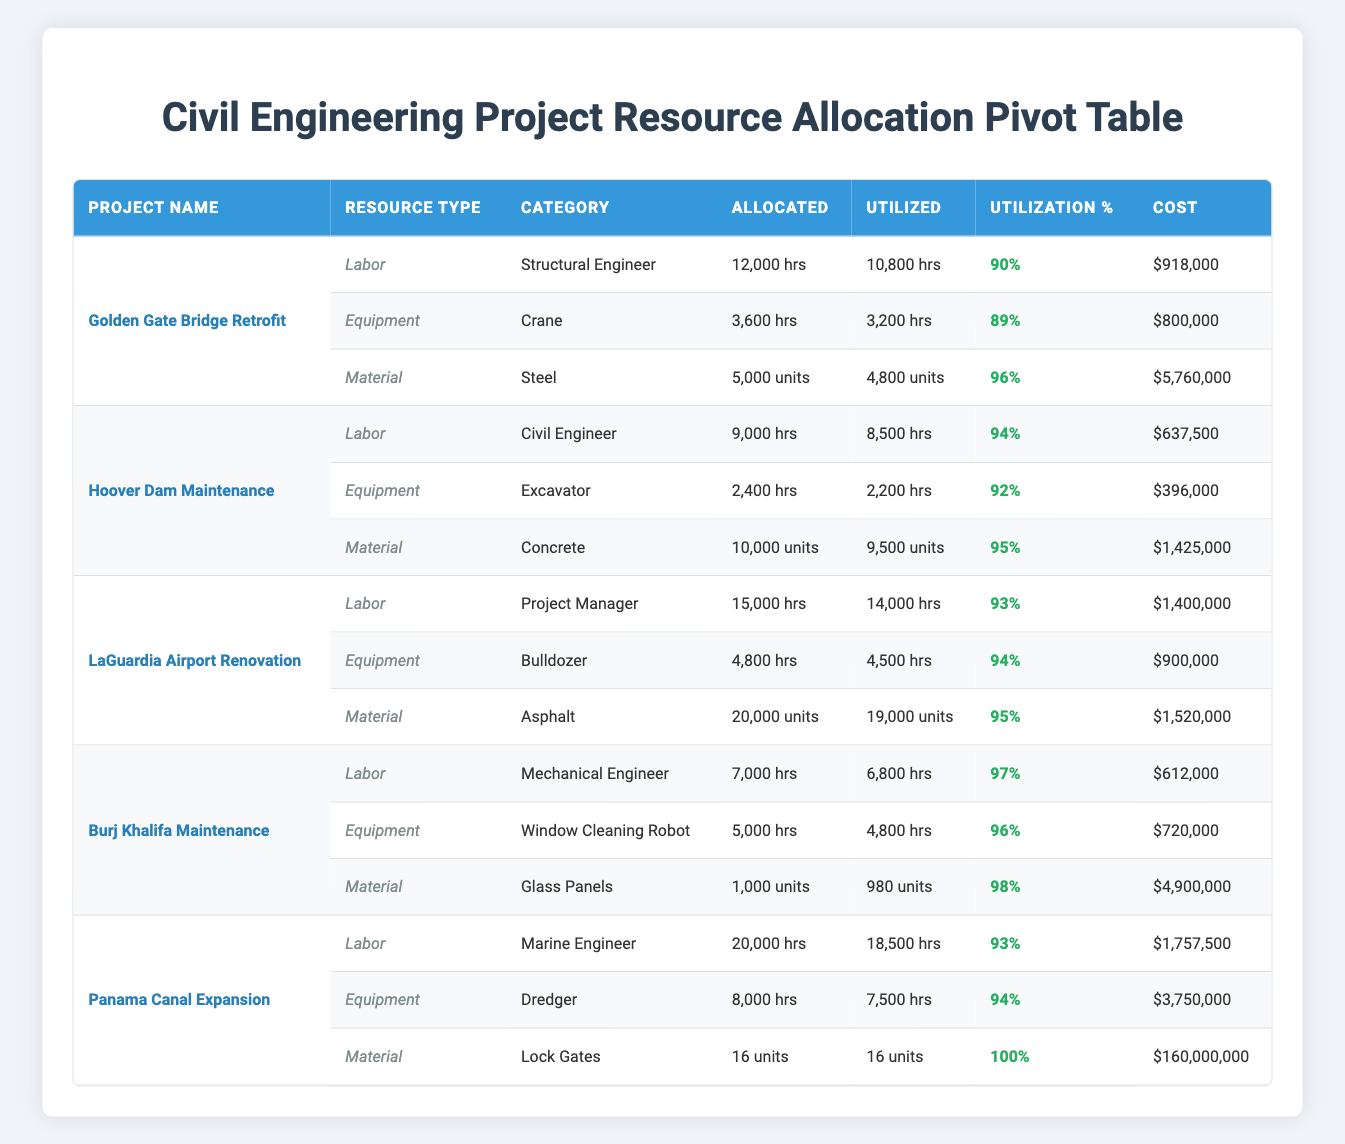What is the total budget for all projects? The total budget can be calculated by adding the budgets of all projects: 250,000,000 + 180,000,000 + 500,000,000 + 100,000,000 + 750,000,000 = 1,780,000,000.
Answer: 1,780,000,000 Which project has the highest resource utilization for Labor? By comparing the Labor utilization percentages for each project, we find the highest is from "Burj Khalifa Maintenance" at 97%.
Answer: Burj Khalifa Maintenance How many hours was Equipment utilized for the Panama Canal Expansion? The table states that Equipment for the Panama Canal Expansion had a utilization of 7,500 hours.
Answer: 7,500 hrs Is the utilization percentage for Steel higher than that for Concrete? The utilization for Steel is 96% and for Concrete is 95%. Since 96% is greater than 95%, the statement is true.
Answer: Yes What is the total cost incurred for Labor across all projects? The total Labor cost is calculated as follows: 918,000 + 637,500 + 1,400,000 + 612,000 + 1,757,500 = 5,325,000.
Answer: 5,325,000 Which project had the most hours allocated for Equipment? By comparing the hours allocated for Equipment across all projects, the "Panama Canal Expansion" allocated the most hours, resulting in 8,000 hours.
Answer: Panama Canal Expansion What is the average utilization percentage of materials across all projects? The utilization percentages are: Steel 96%, Concrete 95%, Asphalt 95%, Glass Panels 98%, and Lock Gates 100%. Sum them up to get 96 + 95 + 95 + 98 + 100 = 484, and then divide by 5 to find the average: 484 / 5 = 96.8%.
Answer: 96.8% Which type of resource had the highest total cost in the Golden Gate Bridge Retrofit project? The costs for resources in this project are: Labor at 918,000, Equipment at 800,000, and Material at 5,760,000. Therefore, Material with 5,760,000 is the highest cost.
Answer: Material How many resources had higher than 90% utilization in the LaGuardia Airport Renovation project? In this project, the utilization percentages are Labor at 93%, Equipment at 94%, and Material at 95%. All three resources exceed 90%, so the total is 3 resources.
Answer: 3 